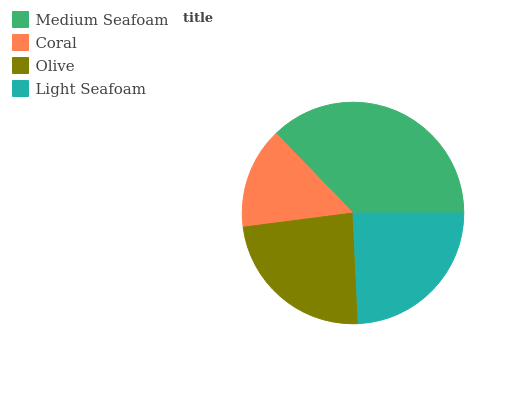Is Coral the minimum?
Answer yes or no. Yes. Is Medium Seafoam the maximum?
Answer yes or no. Yes. Is Olive the minimum?
Answer yes or no. No. Is Olive the maximum?
Answer yes or no. No. Is Olive greater than Coral?
Answer yes or no. Yes. Is Coral less than Olive?
Answer yes or no. Yes. Is Coral greater than Olive?
Answer yes or no. No. Is Olive less than Coral?
Answer yes or no. No. Is Light Seafoam the high median?
Answer yes or no. Yes. Is Olive the low median?
Answer yes or no. Yes. Is Coral the high median?
Answer yes or no. No. Is Medium Seafoam the low median?
Answer yes or no. No. 